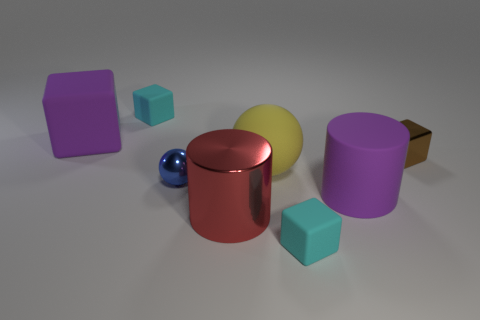Subtract all tiny shiny cubes. How many cubes are left? 3 Add 2 large purple cylinders. How many objects exist? 10 Subtract all red balls. How many cyan cubes are left? 2 Subtract all cyan cubes. How many cubes are left? 2 Subtract all cylinders. How many objects are left? 6 Subtract all big purple matte cylinders. Subtract all small brown objects. How many objects are left? 6 Add 2 shiny objects. How many shiny objects are left? 5 Add 3 tiny cubes. How many tiny cubes exist? 6 Subtract 0 purple spheres. How many objects are left? 8 Subtract 2 balls. How many balls are left? 0 